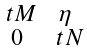<formula> <loc_0><loc_0><loc_500><loc_500>\begin{smallmatrix} \ t M & \eta \\ 0 & \ t N \end{smallmatrix}</formula> 